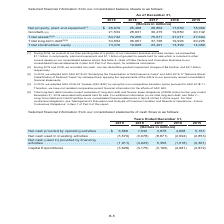According to Centurylink's financial document, What does total long-term debt include? current maturities of long-term debt and finance lease obligations of $305 million for the year ended December 31, 2016 associated with assets held for sale. The document states: "(5) Total long-term debt includes current maturities of long-term debt and finance lease obligations of $305 million for the year ended December 31, 2..." Also, Regarding the total assets, what was adopted in 2019? ASU 2016-02 “Leases (ASC 842)” by using the non-comparative transition option pursuant to ASU 2018-11. The document states: "(4) In 2019, we adopted ASU 2016-02 “Leases (ASC 842)” by using the non-comparative transition option pursuant to ASU 2018-11. Therefore, we have not ..." Also, Which items were reclassified to assets held for sale in 2016? The document shows two values: net property, plant and equipment and goodwill. From the document: "ipment (1) . $ 26,079 26,408 26,852 17,039 18,069 Goodwill (1)(2) . 21,534 28,031 30,475 19,650 20,742 Total assets (3)(4) . 64,742 70,256 75,611 47,0..." Also, How many years was the total stockholders' equity above $14,000 million? Counting the relevant items in the document: 2018, 2017, 2015, I find 3 instances. The key data points involved are: 2015, 2017, 2018. Also, can you calculate: What is the change in goodwill from 2016 to 2017? Based on the calculation: 30,475-19,650, the result is 10825 (in millions). This is based on the information: "039 18,069 Goodwill (1)(2) . 21,534 28,031 30,475 19,650 20,742 Total assets (3)(4) . 64,742 70,256 75,611 47,017 47,604 Total long-term debt (3)(5) . 34,69 852 17,039 18,069 Goodwill (1)(2) . 21,534 ..." The key data points involved are: 19,650, 30,475. Also, can you calculate: What is the average amount of goodwill for 2016 and 2017? To answer this question, I need to perform calculations using the financial data. The calculation is: (30,475+19,650)/2, which equals 25062.5 (in millions). This is based on the information: "039 18,069 Goodwill (1)(2) . 21,534 28,031 30,475 19,650 20,742 Total assets (3)(4) . 64,742 70,256 75,611 47,017 47,604 Total long-term debt (3)(5) . 34,69 852 17,039 18,069 Goodwill (1)(2) . 21,534 ..." The key data points involved are: 19,650, 30,475. 